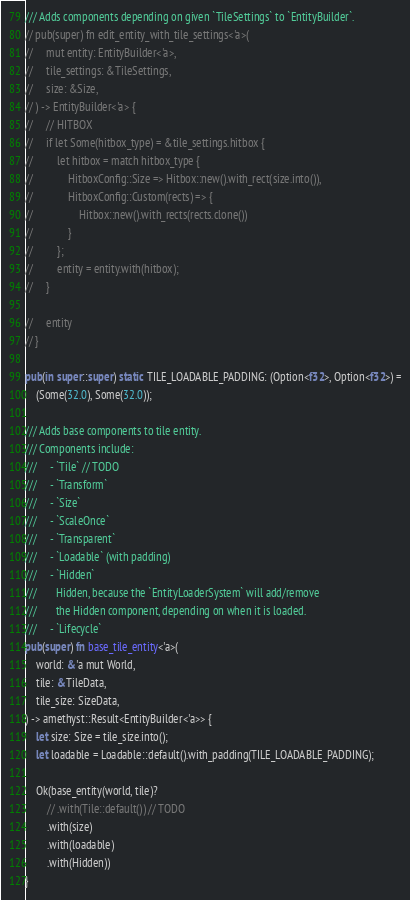<code> <loc_0><loc_0><loc_500><loc_500><_Rust_>
/// Adds components depending on given `TileSettings` to `EntityBuilder`.
// pub(super) fn edit_entity_with_tile_settings<'a>(
//     mut entity: EntityBuilder<'a>,
//     tile_settings: &TileSettings,
//     size: &Size,
// ) -> EntityBuilder<'a> {
//     // HITBOX
//     if let Some(hitbox_type) = &tile_settings.hitbox {
//         let hitbox = match hitbox_type {
//             HitboxConfig::Size => Hitbox::new().with_rect(size.into()),
//             HitboxConfig::Custom(rects) => {
//                 Hitbox::new().with_rects(rects.clone())
//             }
//         };
//         entity = entity.with(hitbox);
//     }

//     entity
// }

pub(in super::super) static TILE_LOADABLE_PADDING: (Option<f32>, Option<f32>) =
    (Some(32.0), Some(32.0));

/// Adds base components to tile entity.
/// Components include:
///     - `Tile` // TODO
///     - `Transform`
///     - `Size`
///     - `ScaleOnce`
///     - `Transparent`
///     - `Loadable` (with padding)
///     - `Hidden`
///       Hidden, because the `EntityLoaderSystem` will add/remove
///       the Hidden component, depending on when it is loaded.
///     - `Lifecycle`
pub(super) fn base_tile_entity<'a>(
    world: &'a mut World,
    tile: &TileData,
    tile_size: SizeData,
) -> amethyst::Result<EntityBuilder<'a>> {
    let size: Size = tile_size.into();
    let loadable = Loadable::default().with_padding(TILE_LOADABLE_PADDING);

    Ok(base_entity(world, tile)?
        // .with(Tile::default()) // TODO
        .with(size)
        .with(loadable)
        .with(Hidden))
}
</code> 